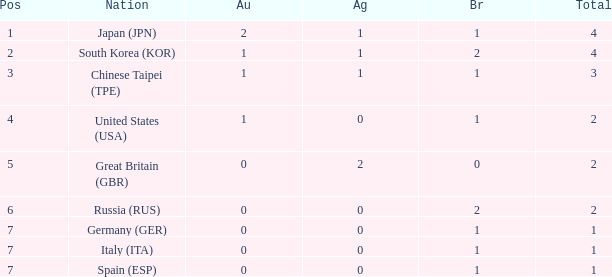How many total medals does a country with more than 1 silver medals have? 2.0. 